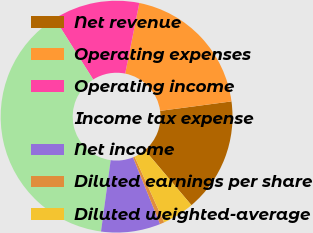<chart> <loc_0><loc_0><loc_500><loc_500><pie_chart><fcel>Net revenue<fcel>Operating expenses<fcel>Operating income<fcel>Income tax expense<fcel>Net income<fcel>Diluted earnings per share<fcel>Diluted weighted-average<nl><fcel>15.93%<fcel>19.76%<fcel>12.1%<fcel>38.91%<fcel>8.27%<fcel>0.61%<fcel>4.44%<nl></chart> 